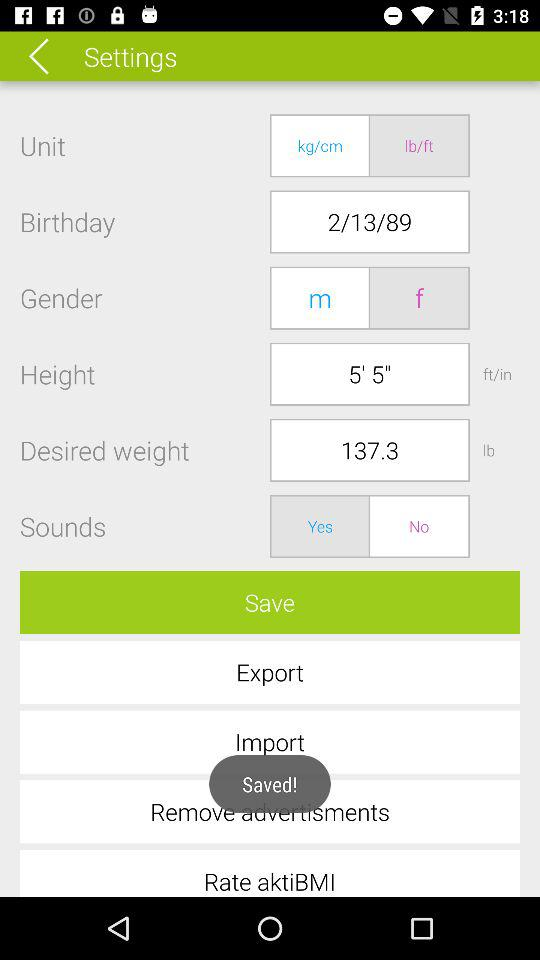What is the desired weight? The desired weight is 137.3 lbs. 